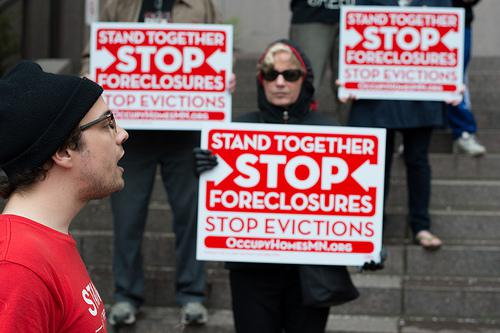Question: who is on the left side?
Choices:
A. A man.
B. Lady.
C. Set of triplets.
D. Dog.
Answer with the letter. Answer: A Question: what are people protesting?
Choices:
A. Labor disputes.
B. Foreclosures and evictions.
C. Rally.
D. Ticket prices.
Answer with the letter. Answer: B Question: what are people holding?
Choices:
A. Phones.
B. Laptops.
C. Signs.
D. Babies.
Answer with the letter. Answer: C Question: what color is the man's shirt?
Choices:
A. White.
B. Red.
C. Black.
D. Blue.
Answer with the letter. Answer: B Question: where are the people standing?
Choices:
A. On stairs.
B. Ground.
C. Grass.
D. Mud.
Answer with the letter. Answer: A Question: who is in the middle?
Choices:
A. A woman.
B. Dog.
C. Cat.
D. Horse.
Answer with the letter. Answer: A 